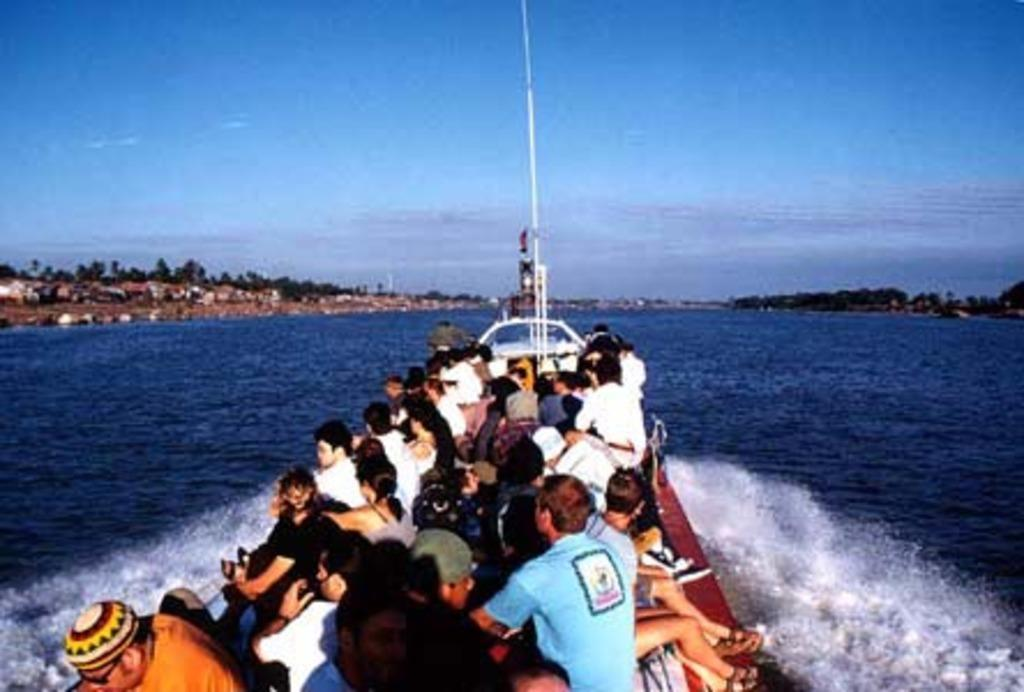What is happening in the image? There is a group of men and women in a boat. What is the boat floating on? The boat is on blue water. What can be seen in the background of the image? There are trees and houses in the background of the image. What type of flower is growing on the boat in the image? There is no flower growing on the boat in the image. 